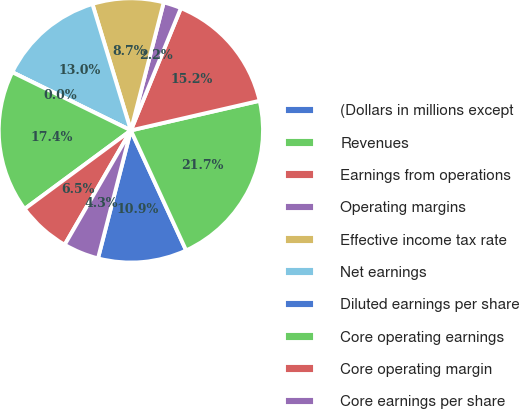<chart> <loc_0><loc_0><loc_500><loc_500><pie_chart><fcel>(Dollars in millions except<fcel>Revenues<fcel>Earnings from operations<fcel>Operating margins<fcel>Effective income tax rate<fcel>Net earnings<fcel>Diluted earnings per share<fcel>Core operating earnings<fcel>Core operating margin<fcel>Core earnings per share<nl><fcel>10.87%<fcel>21.74%<fcel>15.22%<fcel>2.18%<fcel>8.7%<fcel>13.04%<fcel>0.0%<fcel>17.39%<fcel>6.52%<fcel>4.35%<nl></chart> 